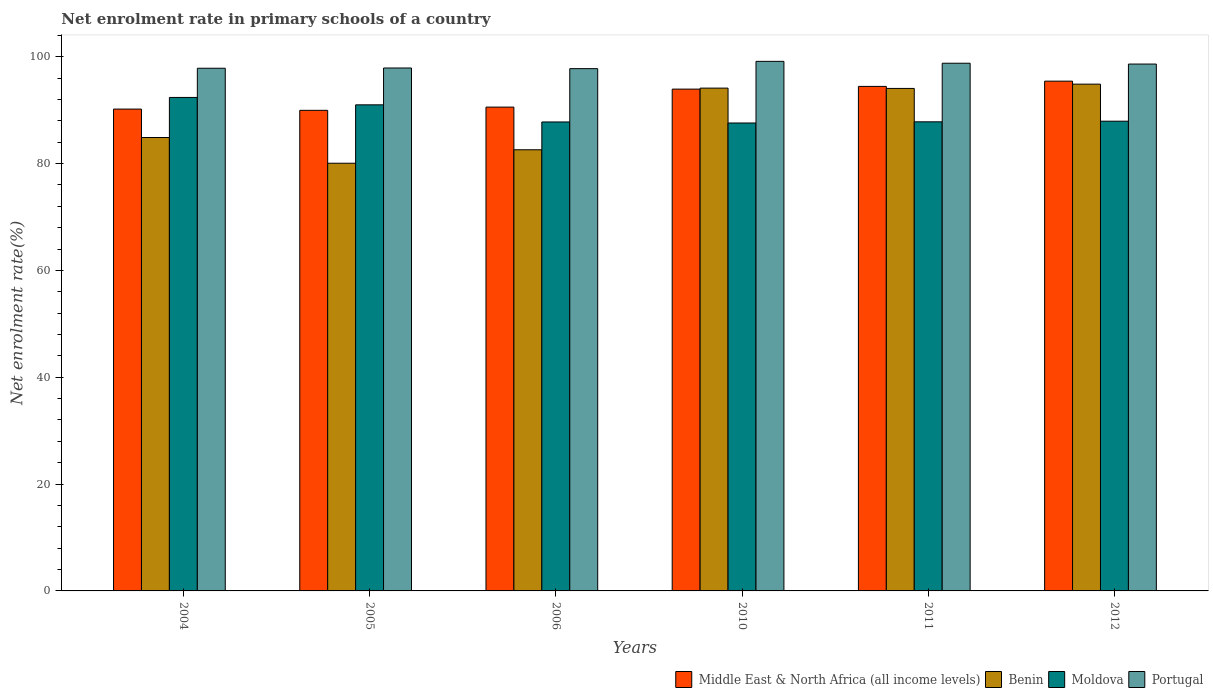How many bars are there on the 4th tick from the left?
Provide a succinct answer. 4. How many bars are there on the 3rd tick from the right?
Your response must be concise. 4. What is the net enrolment rate in primary schools in Middle East & North Africa (all income levels) in 2005?
Offer a very short reply. 89.96. Across all years, what is the maximum net enrolment rate in primary schools in Moldova?
Offer a terse response. 92.37. Across all years, what is the minimum net enrolment rate in primary schools in Middle East & North Africa (all income levels)?
Your response must be concise. 89.96. In which year was the net enrolment rate in primary schools in Portugal minimum?
Your answer should be compact. 2006. What is the total net enrolment rate in primary schools in Moldova in the graph?
Your answer should be very brief. 534.48. What is the difference between the net enrolment rate in primary schools in Middle East & North Africa (all income levels) in 2011 and that in 2012?
Your answer should be very brief. -0.98. What is the difference between the net enrolment rate in primary schools in Portugal in 2010 and the net enrolment rate in primary schools in Benin in 2004?
Your answer should be very brief. 14.26. What is the average net enrolment rate in primary schools in Moldova per year?
Your answer should be compact. 89.08. In the year 2004, what is the difference between the net enrolment rate in primary schools in Middle East & North Africa (all income levels) and net enrolment rate in primary schools in Benin?
Your response must be concise. 5.32. In how many years, is the net enrolment rate in primary schools in Middle East & North Africa (all income levels) greater than 24 %?
Ensure brevity in your answer.  6. What is the ratio of the net enrolment rate in primary schools in Portugal in 2005 to that in 2006?
Offer a terse response. 1. Is the difference between the net enrolment rate in primary schools in Middle East & North Africa (all income levels) in 2006 and 2011 greater than the difference between the net enrolment rate in primary schools in Benin in 2006 and 2011?
Provide a succinct answer. Yes. What is the difference between the highest and the second highest net enrolment rate in primary schools in Benin?
Give a very brief answer. 0.74. What is the difference between the highest and the lowest net enrolment rate in primary schools in Moldova?
Provide a short and direct response. 4.78. In how many years, is the net enrolment rate in primary schools in Moldova greater than the average net enrolment rate in primary schools in Moldova taken over all years?
Your answer should be compact. 2. Is it the case that in every year, the sum of the net enrolment rate in primary schools in Benin and net enrolment rate in primary schools in Portugal is greater than the sum of net enrolment rate in primary schools in Moldova and net enrolment rate in primary schools in Middle East & North Africa (all income levels)?
Your response must be concise. Yes. What does the 1st bar from the left in 2010 represents?
Give a very brief answer. Middle East & North Africa (all income levels). What does the 3rd bar from the right in 2005 represents?
Keep it short and to the point. Benin. Is it the case that in every year, the sum of the net enrolment rate in primary schools in Portugal and net enrolment rate in primary schools in Benin is greater than the net enrolment rate in primary schools in Middle East & North Africa (all income levels)?
Your response must be concise. Yes. How many years are there in the graph?
Ensure brevity in your answer.  6. Does the graph contain any zero values?
Your response must be concise. No. Where does the legend appear in the graph?
Your answer should be compact. Bottom right. How are the legend labels stacked?
Keep it short and to the point. Horizontal. What is the title of the graph?
Keep it short and to the point. Net enrolment rate in primary schools of a country. What is the label or title of the X-axis?
Keep it short and to the point. Years. What is the label or title of the Y-axis?
Provide a short and direct response. Net enrolment rate(%). What is the Net enrolment rate(%) of Middle East & North Africa (all income levels) in 2004?
Provide a short and direct response. 90.2. What is the Net enrolment rate(%) of Benin in 2004?
Your answer should be compact. 84.87. What is the Net enrolment rate(%) in Moldova in 2004?
Offer a terse response. 92.37. What is the Net enrolment rate(%) in Portugal in 2004?
Keep it short and to the point. 97.84. What is the Net enrolment rate(%) of Middle East & North Africa (all income levels) in 2005?
Make the answer very short. 89.96. What is the Net enrolment rate(%) of Benin in 2005?
Keep it short and to the point. 80.06. What is the Net enrolment rate(%) of Moldova in 2005?
Your answer should be compact. 90.99. What is the Net enrolment rate(%) in Portugal in 2005?
Your response must be concise. 97.89. What is the Net enrolment rate(%) of Middle East & North Africa (all income levels) in 2006?
Your answer should be compact. 90.57. What is the Net enrolment rate(%) of Benin in 2006?
Offer a terse response. 82.58. What is the Net enrolment rate(%) in Moldova in 2006?
Keep it short and to the point. 87.79. What is the Net enrolment rate(%) in Portugal in 2006?
Your answer should be compact. 97.76. What is the Net enrolment rate(%) in Middle East & North Africa (all income levels) in 2010?
Your answer should be compact. 93.93. What is the Net enrolment rate(%) of Benin in 2010?
Your answer should be compact. 94.12. What is the Net enrolment rate(%) of Moldova in 2010?
Offer a terse response. 87.59. What is the Net enrolment rate(%) in Portugal in 2010?
Give a very brief answer. 99.13. What is the Net enrolment rate(%) in Middle East & North Africa (all income levels) in 2011?
Give a very brief answer. 94.44. What is the Net enrolment rate(%) of Benin in 2011?
Offer a very short reply. 94.06. What is the Net enrolment rate(%) of Moldova in 2011?
Make the answer very short. 87.81. What is the Net enrolment rate(%) in Portugal in 2011?
Ensure brevity in your answer.  98.78. What is the Net enrolment rate(%) of Middle East & North Africa (all income levels) in 2012?
Keep it short and to the point. 95.43. What is the Net enrolment rate(%) of Benin in 2012?
Provide a succinct answer. 94.86. What is the Net enrolment rate(%) of Moldova in 2012?
Give a very brief answer. 87.93. What is the Net enrolment rate(%) of Portugal in 2012?
Provide a short and direct response. 98.62. Across all years, what is the maximum Net enrolment rate(%) of Middle East & North Africa (all income levels)?
Keep it short and to the point. 95.43. Across all years, what is the maximum Net enrolment rate(%) in Benin?
Provide a short and direct response. 94.86. Across all years, what is the maximum Net enrolment rate(%) of Moldova?
Ensure brevity in your answer.  92.37. Across all years, what is the maximum Net enrolment rate(%) in Portugal?
Provide a succinct answer. 99.13. Across all years, what is the minimum Net enrolment rate(%) in Middle East & North Africa (all income levels)?
Provide a succinct answer. 89.96. Across all years, what is the minimum Net enrolment rate(%) of Benin?
Provide a succinct answer. 80.06. Across all years, what is the minimum Net enrolment rate(%) in Moldova?
Provide a succinct answer. 87.59. Across all years, what is the minimum Net enrolment rate(%) of Portugal?
Offer a very short reply. 97.76. What is the total Net enrolment rate(%) in Middle East & North Africa (all income levels) in the graph?
Make the answer very short. 554.52. What is the total Net enrolment rate(%) of Benin in the graph?
Your answer should be compact. 530.56. What is the total Net enrolment rate(%) in Moldova in the graph?
Make the answer very short. 534.48. What is the total Net enrolment rate(%) in Portugal in the graph?
Provide a short and direct response. 590.03. What is the difference between the Net enrolment rate(%) of Middle East & North Africa (all income levels) in 2004 and that in 2005?
Ensure brevity in your answer.  0.23. What is the difference between the Net enrolment rate(%) in Benin in 2004 and that in 2005?
Provide a short and direct response. 4.81. What is the difference between the Net enrolment rate(%) of Moldova in 2004 and that in 2005?
Your response must be concise. 1.38. What is the difference between the Net enrolment rate(%) of Portugal in 2004 and that in 2005?
Your response must be concise. -0.05. What is the difference between the Net enrolment rate(%) in Middle East & North Africa (all income levels) in 2004 and that in 2006?
Keep it short and to the point. -0.37. What is the difference between the Net enrolment rate(%) of Benin in 2004 and that in 2006?
Offer a terse response. 2.29. What is the difference between the Net enrolment rate(%) in Moldova in 2004 and that in 2006?
Give a very brief answer. 4.59. What is the difference between the Net enrolment rate(%) in Portugal in 2004 and that in 2006?
Offer a very short reply. 0.08. What is the difference between the Net enrolment rate(%) of Middle East & North Africa (all income levels) in 2004 and that in 2010?
Provide a short and direct response. -3.74. What is the difference between the Net enrolment rate(%) of Benin in 2004 and that in 2010?
Provide a succinct answer. -9.25. What is the difference between the Net enrolment rate(%) in Moldova in 2004 and that in 2010?
Your answer should be very brief. 4.78. What is the difference between the Net enrolment rate(%) of Portugal in 2004 and that in 2010?
Make the answer very short. -1.29. What is the difference between the Net enrolment rate(%) in Middle East & North Africa (all income levels) in 2004 and that in 2011?
Make the answer very short. -4.25. What is the difference between the Net enrolment rate(%) in Benin in 2004 and that in 2011?
Ensure brevity in your answer.  -9.19. What is the difference between the Net enrolment rate(%) in Moldova in 2004 and that in 2011?
Make the answer very short. 4.56. What is the difference between the Net enrolment rate(%) of Portugal in 2004 and that in 2011?
Your response must be concise. -0.94. What is the difference between the Net enrolment rate(%) of Middle East & North Africa (all income levels) in 2004 and that in 2012?
Provide a short and direct response. -5.23. What is the difference between the Net enrolment rate(%) of Benin in 2004 and that in 2012?
Offer a terse response. -9.99. What is the difference between the Net enrolment rate(%) in Moldova in 2004 and that in 2012?
Keep it short and to the point. 4.45. What is the difference between the Net enrolment rate(%) of Portugal in 2004 and that in 2012?
Ensure brevity in your answer.  -0.78. What is the difference between the Net enrolment rate(%) of Middle East & North Africa (all income levels) in 2005 and that in 2006?
Give a very brief answer. -0.6. What is the difference between the Net enrolment rate(%) in Benin in 2005 and that in 2006?
Keep it short and to the point. -2.52. What is the difference between the Net enrolment rate(%) of Moldova in 2005 and that in 2006?
Your answer should be very brief. 3.2. What is the difference between the Net enrolment rate(%) in Portugal in 2005 and that in 2006?
Provide a short and direct response. 0.12. What is the difference between the Net enrolment rate(%) of Middle East & North Africa (all income levels) in 2005 and that in 2010?
Make the answer very short. -3.97. What is the difference between the Net enrolment rate(%) in Benin in 2005 and that in 2010?
Provide a short and direct response. -14.06. What is the difference between the Net enrolment rate(%) in Moldova in 2005 and that in 2010?
Your answer should be very brief. 3.4. What is the difference between the Net enrolment rate(%) of Portugal in 2005 and that in 2010?
Keep it short and to the point. -1.24. What is the difference between the Net enrolment rate(%) in Middle East & North Africa (all income levels) in 2005 and that in 2011?
Your answer should be very brief. -4.48. What is the difference between the Net enrolment rate(%) in Benin in 2005 and that in 2011?
Offer a terse response. -14. What is the difference between the Net enrolment rate(%) of Moldova in 2005 and that in 2011?
Provide a short and direct response. 3.18. What is the difference between the Net enrolment rate(%) in Portugal in 2005 and that in 2011?
Your answer should be very brief. -0.89. What is the difference between the Net enrolment rate(%) in Middle East & North Africa (all income levels) in 2005 and that in 2012?
Your answer should be very brief. -5.46. What is the difference between the Net enrolment rate(%) in Benin in 2005 and that in 2012?
Ensure brevity in your answer.  -14.8. What is the difference between the Net enrolment rate(%) of Moldova in 2005 and that in 2012?
Keep it short and to the point. 3.06. What is the difference between the Net enrolment rate(%) in Portugal in 2005 and that in 2012?
Make the answer very short. -0.73. What is the difference between the Net enrolment rate(%) of Middle East & North Africa (all income levels) in 2006 and that in 2010?
Provide a short and direct response. -3.37. What is the difference between the Net enrolment rate(%) of Benin in 2006 and that in 2010?
Keep it short and to the point. -11.54. What is the difference between the Net enrolment rate(%) of Moldova in 2006 and that in 2010?
Provide a short and direct response. 0.19. What is the difference between the Net enrolment rate(%) in Portugal in 2006 and that in 2010?
Provide a short and direct response. -1.37. What is the difference between the Net enrolment rate(%) of Middle East & North Africa (all income levels) in 2006 and that in 2011?
Provide a succinct answer. -3.88. What is the difference between the Net enrolment rate(%) of Benin in 2006 and that in 2011?
Your response must be concise. -11.48. What is the difference between the Net enrolment rate(%) in Moldova in 2006 and that in 2011?
Your answer should be very brief. -0.03. What is the difference between the Net enrolment rate(%) in Portugal in 2006 and that in 2011?
Provide a short and direct response. -1.02. What is the difference between the Net enrolment rate(%) of Middle East & North Africa (all income levels) in 2006 and that in 2012?
Give a very brief answer. -4.86. What is the difference between the Net enrolment rate(%) in Benin in 2006 and that in 2012?
Your answer should be compact. -12.28. What is the difference between the Net enrolment rate(%) of Moldova in 2006 and that in 2012?
Ensure brevity in your answer.  -0.14. What is the difference between the Net enrolment rate(%) of Portugal in 2006 and that in 2012?
Provide a succinct answer. -0.86. What is the difference between the Net enrolment rate(%) of Middle East & North Africa (all income levels) in 2010 and that in 2011?
Your answer should be very brief. -0.51. What is the difference between the Net enrolment rate(%) of Benin in 2010 and that in 2011?
Your answer should be very brief. 0.06. What is the difference between the Net enrolment rate(%) of Moldova in 2010 and that in 2011?
Provide a succinct answer. -0.22. What is the difference between the Net enrolment rate(%) in Portugal in 2010 and that in 2011?
Keep it short and to the point. 0.35. What is the difference between the Net enrolment rate(%) in Middle East & North Africa (all income levels) in 2010 and that in 2012?
Your answer should be compact. -1.49. What is the difference between the Net enrolment rate(%) of Benin in 2010 and that in 2012?
Ensure brevity in your answer.  -0.74. What is the difference between the Net enrolment rate(%) of Moldova in 2010 and that in 2012?
Offer a terse response. -0.34. What is the difference between the Net enrolment rate(%) of Portugal in 2010 and that in 2012?
Offer a very short reply. 0.51. What is the difference between the Net enrolment rate(%) in Middle East & North Africa (all income levels) in 2011 and that in 2012?
Your answer should be very brief. -0.98. What is the difference between the Net enrolment rate(%) in Benin in 2011 and that in 2012?
Your answer should be very brief. -0.8. What is the difference between the Net enrolment rate(%) of Moldova in 2011 and that in 2012?
Offer a very short reply. -0.12. What is the difference between the Net enrolment rate(%) in Portugal in 2011 and that in 2012?
Your answer should be compact. 0.16. What is the difference between the Net enrolment rate(%) in Middle East & North Africa (all income levels) in 2004 and the Net enrolment rate(%) in Benin in 2005?
Your answer should be very brief. 10.13. What is the difference between the Net enrolment rate(%) in Middle East & North Africa (all income levels) in 2004 and the Net enrolment rate(%) in Moldova in 2005?
Your answer should be compact. -0.79. What is the difference between the Net enrolment rate(%) in Middle East & North Africa (all income levels) in 2004 and the Net enrolment rate(%) in Portugal in 2005?
Give a very brief answer. -7.69. What is the difference between the Net enrolment rate(%) in Benin in 2004 and the Net enrolment rate(%) in Moldova in 2005?
Ensure brevity in your answer.  -6.12. What is the difference between the Net enrolment rate(%) of Benin in 2004 and the Net enrolment rate(%) of Portugal in 2005?
Provide a succinct answer. -13.01. What is the difference between the Net enrolment rate(%) of Moldova in 2004 and the Net enrolment rate(%) of Portugal in 2005?
Give a very brief answer. -5.51. What is the difference between the Net enrolment rate(%) in Middle East & North Africa (all income levels) in 2004 and the Net enrolment rate(%) in Benin in 2006?
Give a very brief answer. 7.62. What is the difference between the Net enrolment rate(%) of Middle East & North Africa (all income levels) in 2004 and the Net enrolment rate(%) of Moldova in 2006?
Provide a short and direct response. 2.41. What is the difference between the Net enrolment rate(%) in Middle East & North Africa (all income levels) in 2004 and the Net enrolment rate(%) in Portugal in 2006?
Provide a succinct answer. -7.57. What is the difference between the Net enrolment rate(%) of Benin in 2004 and the Net enrolment rate(%) of Moldova in 2006?
Your answer should be very brief. -2.91. What is the difference between the Net enrolment rate(%) in Benin in 2004 and the Net enrolment rate(%) in Portugal in 2006?
Your answer should be compact. -12.89. What is the difference between the Net enrolment rate(%) of Moldova in 2004 and the Net enrolment rate(%) of Portugal in 2006?
Offer a very short reply. -5.39. What is the difference between the Net enrolment rate(%) in Middle East & North Africa (all income levels) in 2004 and the Net enrolment rate(%) in Benin in 2010?
Your answer should be compact. -3.93. What is the difference between the Net enrolment rate(%) in Middle East & North Africa (all income levels) in 2004 and the Net enrolment rate(%) in Moldova in 2010?
Give a very brief answer. 2.6. What is the difference between the Net enrolment rate(%) of Middle East & North Africa (all income levels) in 2004 and the Net enrolment rate(%) of Portugal in 2010?
Provide a short and direct response. -8.94. What is the difference between the Net enrolment rate(%) of Benin in 2004 and the Net enrolment rate(%) of Moldova in 2010?
Your answer should be compact. -2.72. What is the difference between the Net enrolment rate(%) of Benin in 2004 and the Net enrolment rate(%) of Portugal in 2010?
Offer a terse response. -14.26. What is the difference between the Net enrolment rate(%) in Moldova in 2004 and the Net enrolment rate(%) in Portugal in 2010?
Make the answer very short. -6.76. What is the difference between the Net enrolment rate(%) of Middle East & North Africa (all income levels) in 2004 and the Net enrolment rate(%) of Benin in 2011?
Your response must be concise. -3.87. What is the difference between the Net enrolment rate(%) in Middle East & North Africa (all income levels) in 2004 and the Net enrolment rate(%) in Moldova in 2011?
Your response must be concise. 2.38. What is the difference between the Net enrolment rate(%) of Middle East & North Africa (all income levels) in 2004 and the Net enrolment rate(%) of Portugal in 2011?
Offer a terse response. -8.59. What is the difference between the Net enrolment rate(%) of Benin in 2004 and the Net enrolment rate(%) of Moldova in 2011?
Give a very brief answer. -2.94. What is the difference between the Net enrolment rate(%) of Benin in 2004 and the Net enrolment rate(%) of Portugal in 2011?
Provide a succinct answer. -13.91. What is the difference between the Net enrolment rate(%) in Moldova in 2004 and the Net enrolment rate(%) in Portugal in 2011?
Your response must be concise. -6.41. What is the difference between the Net enrolment rate(%) of Middle East & North Africa (all income levels) in 2004 and the Net enrolment rate(%) of Benin in 2012?
Your answer should be very brief. -4.67. What is the difference between the Net enrolment rate(%) of Middle East & North Africa (all income levels) in 2004 and the Net enrolment rate(%) of Moldova in 2012?
Your response must be concise. 2.27. What is the difference between the Net enrolment rate(%) in Middle East & North Africa (all income levels) in 2004 and the Net enrolment rate(%) in Portugal in 2012?
Ensure brevity in your answer.  -8.43. What is the difference between the Net enrolment rate(%) of Benin in 2004 and the Net enrolment rate(%) of Moldova in 2012?
Ensure brevity in your answer.  -3.05. What is the difference between the Net enrolment rate(%) of Benin in 2004 and the Net enrolment rate(%) of Portugal in 2012?
Your answer should be very brief. -13.75. What is the difference between the Net enrolment rate(%) in Moldova in 2004 and the Net enrolment rate(%) in Portugal in 2012?
Provide a succinct answer. -6.25. What is the difference between the Net enrolment rate(%) in Middle East & North Africa (all income levels) in 2005 and the Net enrolment rate(%) in Benin in 2006?
Your response must be concise. 7.38. What is the difference between the Net enrolment rate(%) of Middle East & North Africa (all income levels) in 2005 and the Net enrolment rate(%) of Moldova in 2006?
Your response must be concise. 2.18. What is the difference between the Net enrolment rate(%) in Middle East & North Africa (all income levels) in 2005 and the Net enrolment rate(%) in Portugal in 2006?
Your response must be concise. -7.8. What is the difference between the Net enrolment rate(%) of Benin in 2005 and the Net enrolment rate(%) of Moldova in 2006?
Make the answer very short. -7.72. What is the difference between the Net enrolment rate(%) in Benin in 2005 and the Net enrolment rate(%) in Portugal in 2006?
Your answer should be compact. -17.7. What is the difference between the Net enrolment rate(%) of Moldova in 2005 and the Net enrolment rate(%) of Portugal in 2006?
Make the answer very short. -6.77. What is the difference between the Net enrolment rate(%) in Middle East & North Africa (all income levels) in 2005 and the Net enrolment rate(%) in Benin in 2010?
Provide a short and direct response. -4.16. What is the difference between the Net enrolment rate(%) in Middle East & North Africa (all income levels) in 2005 and the Net enrolment rate(%) in Moldova in 2010?
Offer a very short reply. 2.37. What is the difference between the Net enrolment rate(%) in Middle East & North Africa (all income levels) in 2005 and the Net enrolment rate(%) in Portugal in 2010?
Your response must be concise. -9.17. What is the difference between the Net enrolment rate(%) of Benin in 2005 and the Net enrolment rate(%) of Moldova in 2010?
Make the answer very short. -7.53. What is the difference between the Net enrolment rate(%) of Benin in 2005 and the Net enrolment rate(%) of Portugal in 2010?
Give a very brief answer. -19.07. What is the difference between the Net enrolment rate(%) in Moldova in 2005 and the Net enrolment rate(%) in Portugal in 2010?
Make the answer very short. -8.14. What is the difference between the Net enrolment rate(%) of Middle East & North Africa (all income levels) in 2005 and the Net enrolment rate(%) of Benin in 2011?
Keep it short and to the point. -4.1. What is the difference between the Net enrolment rate(%) of Middle East & North Africa (all income levels) in 2005 and the Net enrolment rate(%) of Moldova in 2011?
Your answer should be compact. 2.15. What is the difference between the Net enrolment rate(%) of Middle East & North Africa (all income levels) in 2005 and the Net enrolment rate(%) of Portugal in 2011?
Offer a very short reply. -8.82. What is the difference between the Net enrolment rate(%) in Benin in 2005 and the Net enrolment rate(%) in Moldova in 2011?
Ensure brevity in your answer.  -7.75. What is the difference between the Net enrolment rate(%) of Benin in 2005 and the Net enrolment rate(%) of Portugal in 2011?
Give a very brief answer. -18.72. What is the difference between the Net enrolment rate(%) of Moldova in 2005 and the Net enrolment rate(%) of Portugal in 2011?
Give a very brief answer. -7.79. What is the difference between the Net enrolment rate(%) in Middle East & North Africa (all income levels) in 2005 and the Net enrolment rate(%) in Benin in 2012?
Offer a very short reply. -4.9. What is the difference between the Net enrolment rate(%) of Middle East & North Africa (all income levels) in 2005 and the Net enrolment rate(%) of Moldova in 2012?
Offer a very short reply. 2.03. What is the difference between the Net enrolment rate(%) in Middle East & North Africa (all income levels) in 2005 and the Net enrolment rate(%) in Portugal in 2012?
Your response must be concise. -8.66. What is the difference between the Net enrolment rate(%) of Benin in 2005 and the Net enrolment rate(%) of Moldova in 2012?
Your answer should be very brief. -7.87. What is the difference between the Net enrolment rate(%) in Benin in 2005 and the Net enrolment rate(%) in Portugal in 2012?
Provide a short and direct response. -18.56. What is the difference between the Net enrolment rate(%) in Moldova in 2005 and the Net enrolment rate(%) in Portugal in 2012?
Offer a very short reply. -7.63. What is the difference between the Net enrolment rate(%) in Middle East & North Africa (all income levels) in 2006 and the Net enrolment rate(%) in Benin in 2010?
Give a very brief answer. -3.56. What is the difference between the Net enrolment rate(%) in Middle East & North Africa (all income levels) in 2006 and the Net enrolment rate(%) in Moldova in 2010?
Keep it short and to the point. 2.97. What is the difference between the Net enrolment rate(%) in Middle East & North Africa (all income levels) in 2006 and the Net enrolment rate(%) in Portugal in 2010?
Keep it short and to the point. -8.56. What is the difference between the Net enrolment rate(%) in Benin in 2006 and the Net enrolment rate(%) in Moldova in 2010?
Offer a very short reply. -5.01. What is the difference between the Net enrolment rate(%) of Benin in 2006 and the Net enrolment rate(%) of Portugal in 2010?
Provide a succinct answer. -16.55. What is the difference between the Net enrolment rate(%) in Moldova in 2006 and the Net enrolment rate(%) in Portugal in 2010?
Your answer should be very brief. -11.34. What is the difference between the Net enrolment rate(%) in Middle East & North Africa (all income levels) in 2006 and the Net enrolment rate(%) in Benin in 2011?
Give a very brief answer. -3.5. What is the difference between the Net enrolment rate(%) of Middle East & North Africa (all income levels) in 2006 and the Net enrolment rate(%) of Moldova in 2011?
Ensure brevity in your answer.  2.75. What is the difference between the Net enrolment rate(%) in Middle East & North Africa (all income levels) in 2006 and the Net enrolment rate(%) in Portugal in 2011?
Your answer should be compact. -8.21. What is the difference between the Net enrolment rate(%) in Benin in 2006 and the Net enrolment rate(%) in Moldova in 2011?
Keep it short and to the point. -5.23. What is the difference between the Net enrolment rate(%) in Benin in 2006 and the Net enrolment rate(%) in Portugal in 2011?
Your answer should be compact. -16.2. What is the difference between the Net enrolment rate(%) in Moldova in 2006 and the Net enrolment rate(%) in Portugal in 2011?
Your response must be concise. -10.99. What is the difference between the Net enrolment rate(%) of Middle East & North Africa (all income levels) in 2006 and the Net enrolment rate(%) of Benin in 2012?
Keep it short and to the point. -4.3. What is the difference between the Net enrolment rate(%) of Middle East & North Africa (all income levels) in 2006 and the Net enrolment rate(%) of Moldova in 2012?
Provide a succinct answer. 2.64. What is the difference between the Net enrolment rate(%) in Middle East & North Africa (all income levels) in 2006 and the Net enrolment rate(%) in Portugal in 2012?
Keep it short and to the point. -8.06. What is the difference between the Net enrolment rate(%) of Benin in 2006 and the Net enrolment rate(%) of Moldova in 2012?
Your answer should be very brief. -5.35. What is the difference between the Net enrolment rate(%) of Benin in 2006 and the Net enrolment rate(%) of Portugal in 2012?
Your answer should be very brief. -16.04. What is the difference between the Net enrolment rate(%) in Moldova in 2006 and the Net enrolment rate(%) in Portugal in 2012?
Make the answer very short. -10.84. What is the difference between the Net enrolment rate(%) of Middle East & North Africa (all income levels) in 2010 and the Net enrolment rate(%) of Benin in 2011?
Offer a terse response. -0.13. What is the difference between the Net enrolment rate(%) in Middle East & North Africa (all income levels) in 2010 and the Net enrolment rate(%) in Moldova in 2011?
Make the answer very short. 6.12. What is the difference between the Net enrolment rate(%) in Middle East & North Africa (all income levels) in 2010 and the Net enrolment rate(%) in Portugal in 2011?
Your answer should be very brief. -4.85. What is the difference between the Net enrolment rate(%) in Benin in 2010 and the Net enrolment rate(%) in Moldova in 2011?
Your answer should be very brief. 6.31. What is the difference between the Net enrolment rate(%) in Benin in 2010 and the Net enrolment rate(%) in Portugal in 2011?
Provide a succinct answer. -4.66. What is the difference between the Net enrolment rate(%) in Moldova in 2010 and the Net enrolment rate(%) in Portugal in 2011?
Ensure brevity in your answer.  -11.19. What is the difference between the Net enrolment rate(%) of Middle East & North Africa (all income levels) in 2010 and the Net enrolment rate(%) of Benin in 2012?
Offer a very short reply. -0.93. What is the difference between the Net enrolment rate(%) of Middle East & North Africa (all income levels) in 2010 and the Net enrolment rate(%) of Moldova in 2012?
Your answer should be compact. 6. What is the difference between the Net enrolment rate(%) in Middle East & North Africa (all income levels) in 2010 and the Net enrolment rate(%) in Portugal in 2012?
Ensure brevity in your answer.  -4.69. What is the difference between the Net enrolment rate(%) of Benin in 2010 and the Net enrolment rate(%) of Moldova in 2012?
Offer a very short reply. 6.19. What is the difference between the Net enrolment rate(%) in Benin in 2010 and the Net enrolment rate(%) in Portugal in 2012?
Your answer should be compact. -4.5. What is the difference between the Net enrolment rate(%) in Moldova in 2010 and the Net enrolment rate(%) in Portugal in 2012?
Provide a short and direct response. -11.03. What is the difference between the Net enrolment rate(%) of Middle East & North Africa (all income levels) in 2011 and the Net enrolment rate(%) of Benin in 2012?
Your answer should be compact. -0.42. What is the difference between the Net enrolment rate(%) in Middle East & North Africa (all income levels) in 2011 and the Net enrolment rate(%) in Moldova in 2012?
Provide a succinct answer. 6.51. What is the difference between the Net enrolment rate(%) of Middle East & North Africa (all income levels) in 2011 and the Net enrolment rate(%) of Portugal in 2012?
Your answer should be compact. -4.18. What is the difference between the Net enrolment rate(%) in Benin in 2011 and the Net enrolment rate(%) in Moldova in 2012?
Make the answer very short. 6.13. What is the difference between the Net enrolment rate(%) in Benin in 2011 and the Net enrolment rate(%) in Portugal in 2012?
Provide a succinct answer. -4.56. What is the difference between the Net enrolment rate(%) of Moldova in 2011 and the Net enrolment rate(%) of Portugal in 2012?
Keep it short and to the point. -10.81. What is the average Net enrolment rate(%) of Middle East & North Africa (all income levels) per year?
Your answer should be compact. 92.42. What is the average Net enrolment rate(%) in Benin per year?
Provide a short and direct response. 88.43. What is the average Net enrolment rate(%) of Moldova per year?
Provide a short and direct response. 89.08. What is the average Net enrolment rate(%) of Portugal per year?
Your answer should be compact. 98.34. In the year 2004, what is the difference between the Net enrolment rate(%) of Middle East & North Africa (all income levels) and Net enrolment rate(%) of Benin?
Your answer should be very brief. 5.32. In the year 2004, what is the difference between the Net enrolment rate(%) in Middle East & North Africa (all income levels) and Net enrolment rate(%) in Moldova?
Provide a short and direct response. -2.18. In the year 2004, what is the difference between the Net enrolment rate(%) of Middle East & North Africa (all income levels) and Net enrolment rate(%) of Portugal?
Make the answer very short. -7.65. In the year 2004, what is the difference between the Net enrolment rate(%) in Benin and Net enrolment rate(%) in Moldova?
Keep it short and to the point. -7.5. In the year 2004, what is the difference between the Net enrolment rate(%) of Benin and Net enrolment rate(%) of Portugal?
Offer a very short reply. -12.97. In the year 2004, what is the difference between the Net enrolment rate(%) of Moldova and Net enrolment rate(%) of Portugal?
Provide a succinct answer. -5.47. In the year 2005, what is the difference between the Net enrolment rate(%) in Middle East & North Africa (all income levels) and Net enrolment rate(%) in Benin?
Keep it short and to the point. 9.9. In the year 2005, what is the difference between the Net enrolment rate(%) of Middle East & North Africa (all income levels) and Net enrolment rate(%) of Moldova?
Provide a succinct answer. -1.03. In the year 2005, what is the difference between the Net enrolment rate(%) of Middle East & North Africa (all income levels) and Net enrolment rate(%) of Portugal?
Keep it short and to the point. -7.93. In the year 2005, what is the difference between the Net enrolment rate(%) in Benin and Net enrolment rate(%) in Moldova?
Your response must be concise. -10.93. In the year 2005, what is the difference between the Net enrolment rate(%) in Benin and Net enrolment rate(%) in Portugal?
Ensure brevity in your answer.  -17.83. In the year 2005, what is the difference between the Net enrolment rate(%) in Moldova and Net enrolment rate(%) in Portugal?
Make the answer very short. -6.9. In the year 2006, what is the difference between the Net enrolment rate(%) of Middle East & North Africa (all income levels) and Net enrolment rate(%) of Benin?
Provide a short and direct response. 7.99. In the year 2006, what is the difference between the Net enrolment rate(%) of Middle East & North Africa (all income levels) and Net enrolment rate(%) of Moldova?
Provide a short and direct response. 2.78. In the year 2006, what is the difference between the Net enrolment rate(%) in Middle East & North Africa (all income levels) and Net enrolment rate(%) in Portugal?
Ensure brevity in your answer.  -7.2. In the year 2006, what is the difference between the Net enrolment rate(%) in Benin and Net enrolment rate(%) in Moldova?
Your answer should be very brief. -5.21. In the year 2006, what is the difference between the Net enrolment rate(%) in Benin and Net enrolment rate(%) in Portugal?
Your answer should be compact. -15.18. In the year 2006, what is the difference between the Net enrolment rate(%) in Moldova and Net enrolment rate(%) in Portugal?
Your response must be concise. -9.98. In the year 2010, what is the difference between the Net enrolment rate(%) in Middle East & North Africa (all income levels) and Net enrolment rate(%) in Benin?
Give a very brief answer. -0.19. In the year 2010, what is the difference between the Net enrolment rate(%) in Middle East & North Africa (all income levels) and Net enrolment rate(%) in Moldova?
Provide a short and direct response. 6.34. In the year 2010, what is the difference between the Net enrolment rate(%) in Middle East & North Africa (all income levels) and Net enrolment rate(%) in Portugal?
Your response must be concise. -5.2. In the year 2010, what is the difference between the Net enrolment rate(%) of Benin and Net enrolment rate(%) of Moldova?
Offer a very short reply. 6.53. In the year 2010, what is the difference between the Net enrolment rate(%) of Benin and Net enrolment rate(%) of Portugal?
Keep it short and to the point. -5.01. In the year 2010, what is the difference between the Net enrolment rate(%) in Moldova and Net enrolment rate(%) in Portugal?
Offer a very short reply. -11.54. In the year 2011, what is the difference between the Net enrolment rate(%) of Middle East & North Africa (all income levels) and Net enrolment rate(%) of Benin?
Offer a very short reply. 0.38. In the year 2011, what is the difference between the Net enrolment rate(%) in Middle East & North Africa (all income levels) and Net enrolment rate(%) in Moldova?
Your response must be concise. 6.63. In the year 2011, what is the difference between the Net enrolment rate(%) in Middle East & North Africa (all income levels) and Net enrolment rate(%) in Portugal?
Give a very brief answer. -4.34. In the year 2011, what is the difference between the Net enrolment rate(%) in Benin and Net enrolment rate(%) in Moldova?
Make the answer very short. 6.25. In the year 2011, what is the difference between the Net enrolment rate(%) of Benin and Net enrolment rate(%) of Portugal?
Offer a very short reply. -4.72. In the year 2011, what is the difference between the Net enrolment rate(%) of Moldova and Net enrolment rate(%) of Portugal?
Ensure brevity in your answer.  -10.97. In the year 2012, what is the difference between the Net enrolment rate(%) in Middle East & North Africa (all income levels) and Net enrolment rate(%) in Benin?
Provide a short and direct response. 0.56. In the year 2012, what is the difference between the Net enrolment rate(%) of Middle East & North Africa (all income levels) and Net enrolment rate(%) of Moldova?
Ensure brevity in your answer.  7.5. In the year 2012, what is the difference between the Net enrolment rate(%) of Middle East & North Africa (all income levels) and Net enrolment rate(%) of Portugal?
Offer a terse response. -3.2. In the year 2012, what is the difference between the Net enrolment rate(%) in Benin and Net enrolment rate(%) in Moldova?
Give a very brief answer. 6.93. In the year 2012, what is the difference between the Net enrolment rate(%) of Benin and Net enrolment rate(%) of Portugal?
Your answer should be compact. -3.76. In the year 2012, what is the difference between the Net enrolment rate(%) in Moldova and Net enrolment rate(%) in Portugal?
Make the answer very short. -10.69. What is the ratio of the Net enrolment rate(%) of Benin in 2004 to that in 2005?
Keep it short and to the point. 1.06. What is the ratio of the Net enrolment rate(%) in Moldova in 2004 to that in 2005?
Offer a terse response. 1.02. What is the ratio of the Net enrolment rate(%) of Middle East & North Africa (all income levels) in 2004 to that in 2006?
Your answer should be compact. 1. What is the ratio of the Net enrolment rate(%) of Benin in 2004 to that in 2006?
Your answer should be compact. 1.03. What is the ratio of the Net enrolment rate(%) in Moldova in 2004 to that in 2006?
Your response must be concise. 1.05. What is the ratio of the Net enrolment rate(%) of Middle East & North Africa (all income levels) in 2004 to that in 2010?
Provide a succinct answer. 0.96. What is the ratio of the Net enrolment rate(%) in Benin in 2004 to that in 2010?
Make the answer very short. 0.9. What is the ratio of the Net enrolment rate(%) in Moldova in 2004 to that in 2010?
Make the answer very short. 1.05. What is the ratio of the Net enrolment rate(%) of Portugal in 2004 to that in 2010?
Ensure brevity in your answer.  0.99. What is the ratio of the Net enrolment rate(%) in Middle East & North Africa (all income levels) in 2004 to that in 2011?
Provide a succinct answer. 0.95. What is the ratio of the Net enrolment rate(%) of Benin in 2004 to that in 2011?
Ensure brevity in your answer.  0.9. What is the ratio of the Net enrolment rate(%) in Moldova in 2004 to that in 2011?
Make the answer very short. 1.05. What is the ratio of the Net enrolment rate(%) of Portugal in 2004 to that in 2011?
Keep it short and to the point. 0.99. What is the ratio of the Net enrolment rate(%) in Middle East & North Africa (all income levels) in 2004 to that in 2012?
Give a very brief answer. 0.95. What is the ratio of the Net enrolment rate(%) of Benin in 2004 to that in 2012?
Give a very brief answer. 0.89. What is the ratio of the Net enrolment rate(%) in Moldova in 2004 to that in 2012?
Provide a short and direct response. 1.05. What is the ratio of the Net enrolment rate(%) in Portugal in 2004 to that in 2012?
Offer a very short reply. 0.99. What is the ratio of the Net enrolment rate(%) in Benin in 2005 to that in 2006?
Keep it short and to the point. 0.97. What is the ratio of the Net enrolment rate(%) in Moldova in 2005 to that in 2006?
Make the answer very short. 1.04. What is the ratio of the Net enrolment rate(%) of Middle East & North Africa (all income levels) in 2005 to that in 2010?
Provide a succinct answer. 0.96. What is the ratio of the Net enrolment rate(%) of Benin in 2005 to that in 2010?
Your answer should be compact. 0.85. What is the ratio of the Net enrolment rate(%) of Moldova in 2005 to that in 2010?
Your response must be concise. 1.04. What is the ratio of the Net enrolment rate(%) in Portugal in 2005 to that in 2010?
Your answer should be compact. 0.99. What is the ratio of the Net enrolment rate(%) in Middle East & North Africa (all income levels) in 2005 to that in 2011?
Provide a short and direct response. 0.95. What is the ratio of the Net enrolment rate(%) of Benin in 2005 to that in 2011?
Your answer should be very brief. 0.85. What is the ratio of the Net enrolment rate(%) of Moldova in 2005 to that in 2011?
Provide a short and direct response. 1.04. What is the ratio of the Net enrolment rate(%) of Portugal in 2005 to that in 2011?
Provide a succinct answer. 0.99. What is the ratio of the Net enrolment rate(%) of Middle East & North Africa (all income levels) in 2005 to that in 2012?
Offer a very short reply. 0.94. What is the ratio of the Net enrolment rate(%) in Benin in 2005 to that in 2012?
Your response must be concise. 0.84. What is the ratio of the Net enrolment rate(%) in Moldova in 2005 to that in 2012?
Give a very brief answer. 1.03. What is the ratio of the Net enrolment rate(%) in Middle East & North Africa (all income levels) in 2006 to that in 2010?
Give a very brief answer. 0.96. What is the ratio of the Net enrolment rate(%) of Benin in 2006 to that in 2010?
Your answer should be very brief. 0.88. What is the ratio of the Net enrolment rate(%) of Portugal in 2006 to that in 2010?
Make the answer very short. 0.99. What is the ratio of the Net enrolment rate(%) in Middle East & North Africa (all income levels) in 2006 to that in 2011?
Offer a very short reply. 0.96. What is the ratio of the Net enrolment rate(%) of Benin in 2006 to that in 2011?
Offer a terse response. 0.88. What is the ratio of the Net enrolment rate(%) in Middle East & North Africa (all income levels) in 2006 to that in 2012?
Your answer should be very brief. 0.95. What is the ratio of the Net enrolment rate(%) in Benin in 2006 to that in 2012?
Your answer should be compact. 0.87. What is the ratio of the Net enrolment rate(%) of Moldova in 2006 to that in 2012?
Make the answer very short. 1. What is the ratio of the Net enrolment rate(%) in Middle East & North Africa (all income levels) in 2010 to that in 2011?
Offer a terse response. 0.99. What is the ratio of the Net enrolment rate(%) of Moldova in 2010 to that in 2011?
Your answer should be very brief. 1. What is the ratio of the Net enrolment rate(%) in Middle East & North Africa (all income levels) in 2010 to that in 2012?
Offer a very short reply. 0.98. What is the ratio of the Net enrolment rate(%) in Benin in 2010 to that in 2012?
Keep it short and to the point. 0.99. What is the ratio of the Net enrolment rate(%) of Moldova in 2010 to that in 2012?
Provide a short and direct response. 1. What is the ratio of the Net enrolment rate(%) in Portugal in 2010 to that in 2012?
Offer a very short reply. 1.01. What is the ratio of the Net enrolment rate(%) in Portugal in 2011 to that in 2012?
Offer a terse response. 1. What is the difference between the highest and the second highest Net enrolment rate(%) in Middle East & North Africa (all income levels)?
Your answer should be very brief. 0.98. What is the difference between the highest and the second highest Net enrolment rate(%) in Benin?
Make the answer very short. 0.74. What is the difference between the highest and the second highest Net enrolment rate(%) of Moldova?
Your answer should be compact. 1.38. What is the difference between the highest and the second highest Net enrolment rate(%) of Portugal?
Keep it short and to the point. 0.35. What is the difference between the highest and the lowest Net enrolment rate(%) of Middle East & North Africa (all income levels)?
Your answer should be very brief. 5.46. What is the difference between the highest and the lowest Net enrolment rate(%) of Benin?
Offer a very short reply. 14.8. What is the difference between the highest and the lowest Net enrolment rate(%) in Moldova?
Offer a very short reply. 4.78. What is the difference between the highest and the lowest Net enrolment rate(%) in Portugal?
Keep it short and to the point. 1.37. 